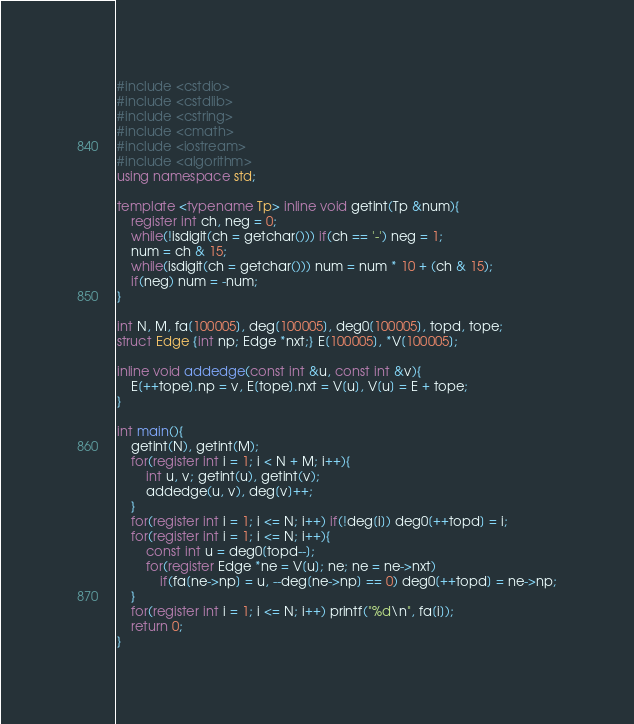<code> <loc_0><loc_0><loc_500><loc_500><_C++_>#include <cstdio>
#include <cstdlib>
#include <cstring>
#include <cmath>
#include <iostream>
#include <algorithm>
using namespace std;

template <typename Tp> inline void getint(Tp &num){
	register int ch, neg = 0;
	while(!isdigit(ch = getchar())) if(ch == '-') neg = 1;
	num = ch & 15;
	while(isdigit(ch = getchar())) num = num * 10 + (ch & 15);
	if(neg) num = -num;
}

int N, M, fa[100005], deg[100005], deg0[100005], topd, tope;
struct Edge {int np; Edge *nxt;} E[100005], *V[100005];

inline void addedge(const int &u, const int &v){
	E[++tope].np = v, E[tope].nxt = V[u], V[u] = E + tope;
}

int main(){
	getint(N), getint(M);
	for(register int i = 1; i < N + M; i++){
		int u, v; getint(u), getint(v);
		addedge(u, v), deg[v]++;
	}
	for(register int i = 1; i <= N; i++) if(!deg[i]) deg0[++topd] = i;
	for(register int i = 1; i <= N; i++){
		const int u = deg0[topd--];
		for(register Edge *ne = V[u]; ne; ne = ne->nxt)
			if(fa[ne->np] = u, --deg[ne->np] == 0) deg0[++topd] = ne->np;
	}
	for(register int i = 1; i <= N; i++) printf("%d\n", fa[i]);
	return 0;
}</code> 